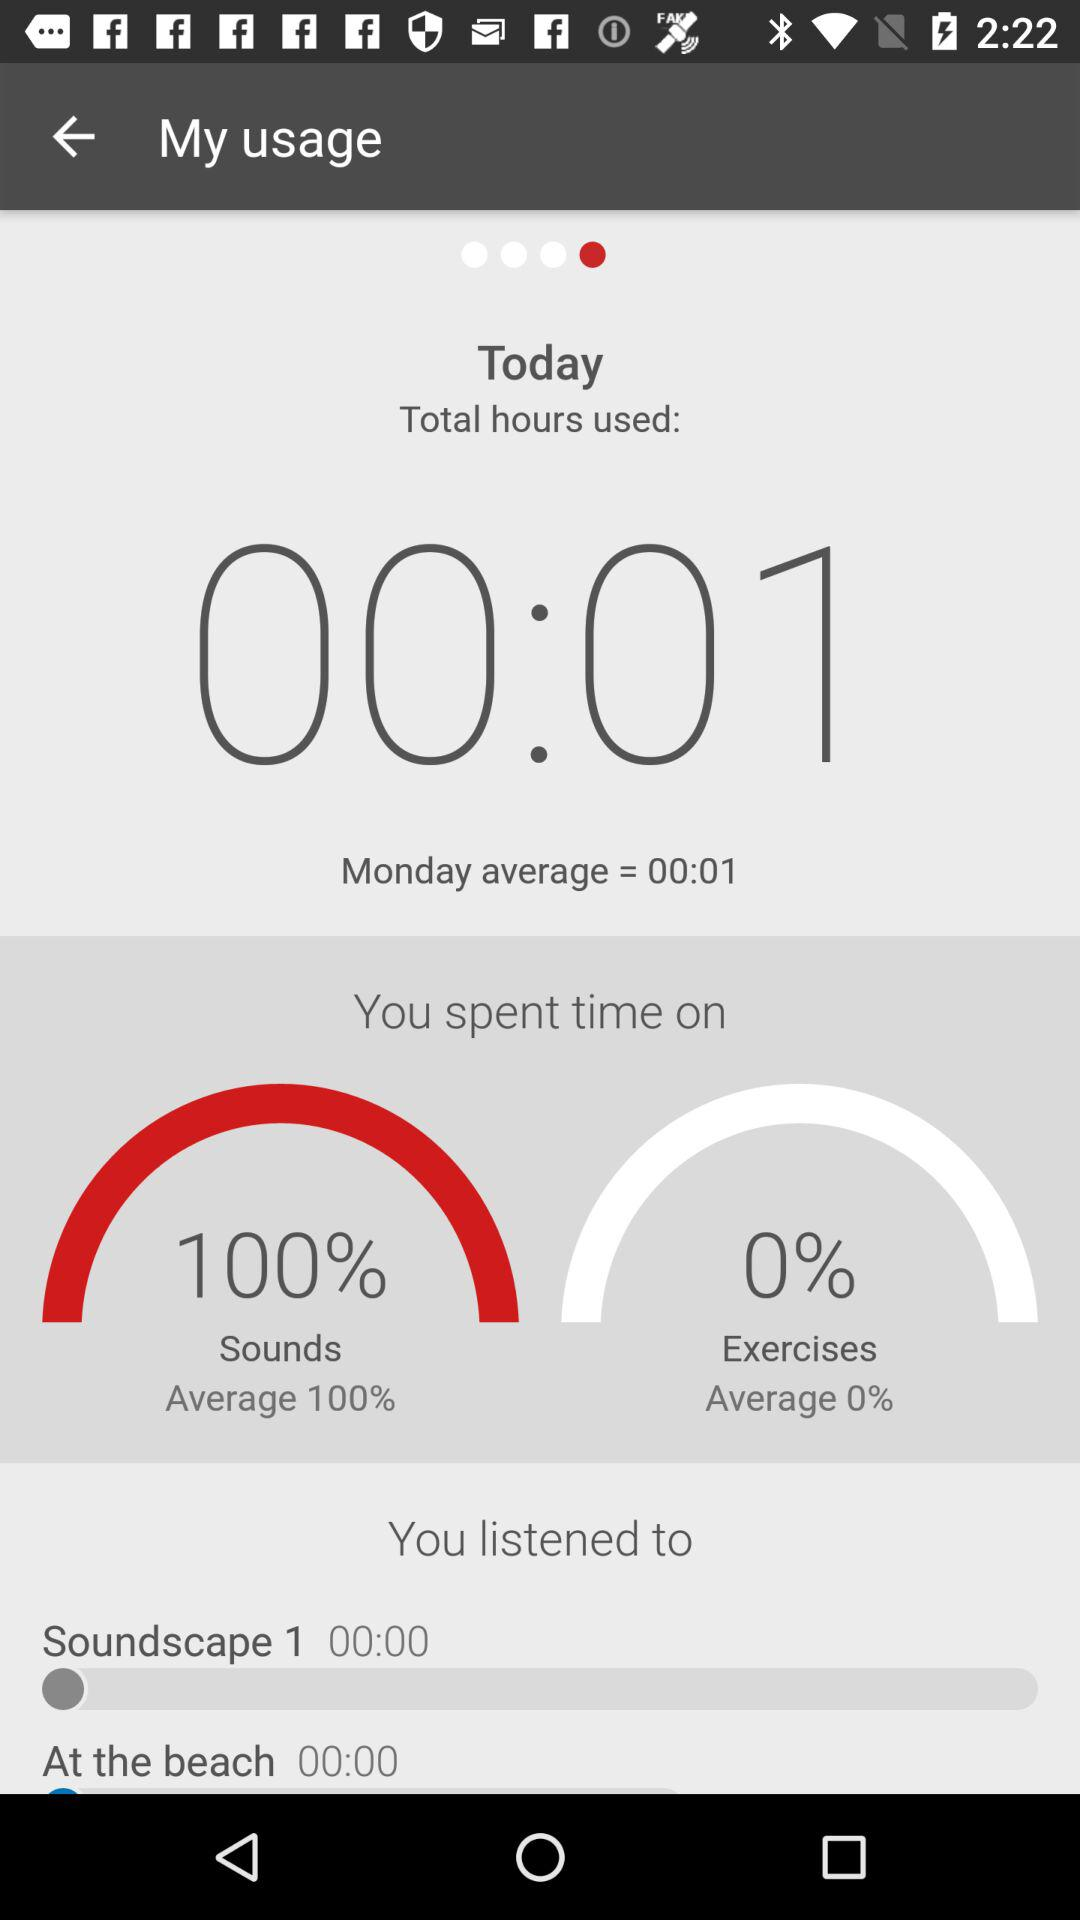What is the average percentage of the sound? The average percentage of the sound is 100. 